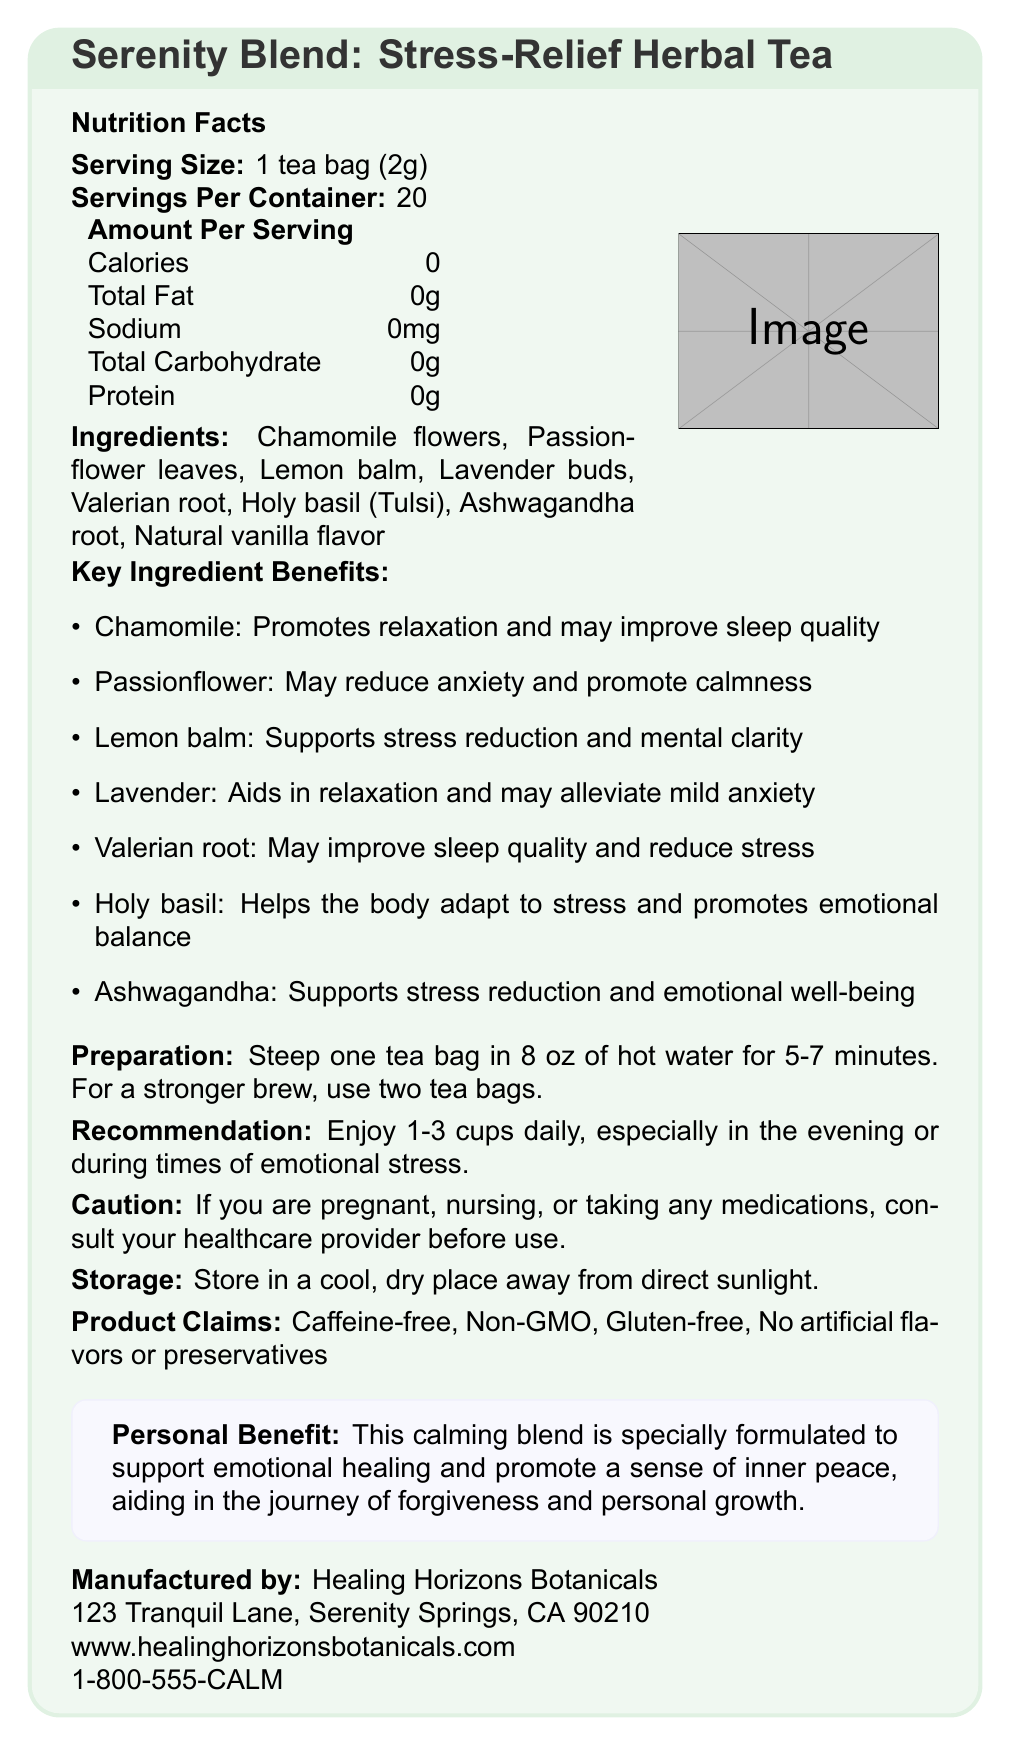What is the name of the product? The name of the product is clearly mentioned at the beginning of the document.
Answer: Serenity Blend: Stress-Relief Herbal Tea How many servings are there per container? The document states that there are 20 servings per container.
Answer: 20 What is the serving size for this tea? The serving size mentioned is 1 tea bag (2g).
Answer: 1 tea bag (2g) Does the tea contain any calories? The document specifies that there are 0 calories per serving.
Answer: No What ingredients are included in this herbal tea blend? These ingredients are listed in the ingredients section of the document.
Answer: Chamomile flowers, Passionflower leaves, Lemon balm, Lavender buds, Valerian root, Holy basil (Tulsi), Ashwagandha root, Natural vanilla flavor What type of product claims does this tea make? A. Contains caffeine B. Non-GMO C. Artificial flavors included The document claims that the product is Non-GMO, caffeine-free, gluten-free, and has no artificial flavors or preservatives.
Answer: B Which ingredient helps in promoting relaxation and might improve sleep quality? A. Lavender B. Valerian root C. Chamomile Chamomile is stated to promote relaxation and may improve sleep quality.
Answer: C How should the tea be prepared? These preparation instructions are provided in the document.
Answer: Steep one tea bag in 8 oz of hot water for 5-7 minutes. For a stronger brew, use two tea bags. Can pregnant women use this herbal tea without consulting a healthcare provider? The cautionary statement advises consulting a healthcare provider if you are pregnant, nursing, or taking any medications.
Answer: No Summarize the main benefit of this herbal tea blend as described in the document. The document emphasizes that the blend is specially formulated for emotional healing and personal growth, helping in the journey of forgiveness.
Answer: The herbal tea blend supports emotional healing, promotes a sense of inner peace, and aids in the journey of forgiveness and personal growth. Is the tea stored in a cool, dry place away from direct sunlight? The storage instructions specify to store the tea in a cool, dry place away from direct sunlight.
Answer: Yes Who is the manufacturer of this product? The manufacturer information section states that Healing Horizons Botanicals is the manufacturer.
Answer: Healing Horizons Botanicals What is the website of the manufacturer? The document lists the manufacturer's website as www.healinghorizonsbotanicals.com.
Answer: www.healinghorizonsbotanicals.com How can one enjoy the tea for the best results? The consumption recommendation suggests drinking 1-3 cups daily during specific times for best results.
Answer: Enjoy 1-3 cups daily, especially in the evening or during times of emotional stress Which ingredient is mentioned as supporting stress reduction and mental clarity? The benefits for Lemon balm are described as supporting stress reduction and mental clarity.
Answer: Lemon balm What telephone number should you call if you want to contact Healing Horizons Botanicals? The manufacturer's contact phone number is listed as 1-800-555-CALM.
Answer: 1-800-555-CALM How many grams of total fat are in one serving of this tea? The nutrition facts state that there are 0g of total fat per serving.
Answer: 0g Where is the manufacturer located? The address provided in the manufacturer information section is 123 Tranquil Lane, Serenity Springs, CA 90210.
Answer: 123 Tranquil Lane, Serenity Springs, CA 90210 What is the effect of Holy Basil in the tea blend? The document lists Holy Basil's benefit as helping the body adapt to stress and promoting emotional balance.
Answer: Helps the body adapt to stress and promotes emotional balance What kind of flavors or preservatives are used in this tea? The document claims that the product uses no artificial flavors or preservatives.
Answer: No artificial flavors or preservatives What is the tea blend's specific benefit related to personal growth? The tea is formulated to aid in personal growth and forgiveness, contributing to emotional healing and inner peace.
Answer: Supports emotional healing and promotes a sense of inner peace, aiding in the journey of forgiveness and personal growth What is the purpose of the valerian root in the tea blend? The valerian root is included for its potential to improve sleep quality and reduce stress.
Answer: May improve sleep quality and reduce stress Who can provide more information about the possible interactions of the tea with medications? The cautionary statement advises consulting a healthcare provider for such information.
Answer: Healthcare provider What is printed on the box for the main title? This question cannot be answered without visual cues from the rendered document.
Answer: \textbf{Serenity Blend: Stress-Relief Herbal Tea} Which herb is described as having a calming effect and may alleviate mild anxiety? Lavender's benefits are listed as aiding in relaxation and possibly alleviating mild anxiety.
Answer: Lavender 